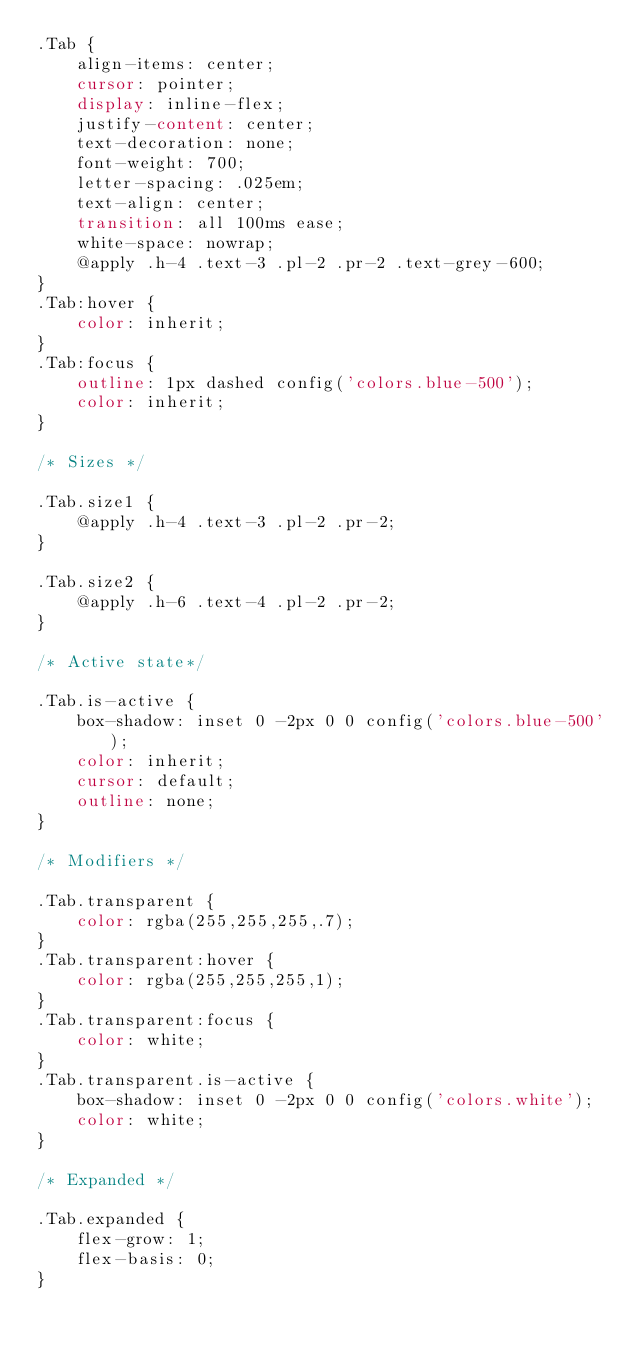Convert code to text. <code><loc_0><loc_0><loc_500><loc_500><_CSS_>.Tab {
    align-items: center;
    cursor: pointer;
    display: inline-flex;
    justify-content: center;
    text-decoration: none;
    font-weight: 700;
    letter-spacing: .025em;
    text-align: center;
    transition: all 100ms ease;
    white-space: nowrap;
    @apply .h-4 .text-3 .pl-2 .pr-2 .text-grey-600;
}
.Tab:hover {
    color: inherit;
}
.Tab:focus {
    outline: 1px dashed config('colors.blue-500');
    color: inherit;
}

/* Sizes */

.Tab.size1 {
    @apply .h-4 .text-3 .pl-2 .pr-2;
}

.Tab.size2 {
    @apply .h-6 .text-4 .pl-2 .pr-2;
}

/* Active state*/

.Tab.is-active {
    box-shadow: inset 0 -2px 0 0 config('colors.blue-500');
    color: inherit;
    cursor: default;
    outline: none;
}

/* Modifiers */

.Tab.transparent {
    color: rgba(255,255,255,.7);
}
.Tab.transparent:hover {
    color: rgba(255,255,255,1);
}
.Tab.transparent:focus {
    color: white;
}
.Tab.transparent.is-active {
    box-shadow: inset 0 -2px 0 0 config('colors.white');
    color: white;
}

/* Expanded */

.Tab.expanded {
    flex-grow: 1;
    flex-basis: 0;
}
</code> 